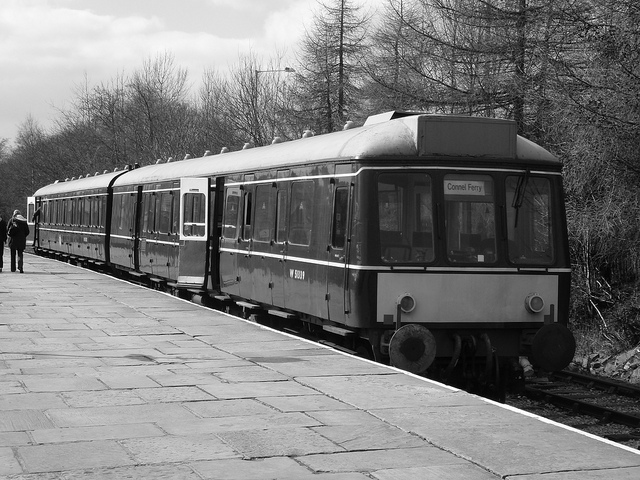What does the sign on the front of the train say? The sign on the front of the train reads 'Cornell Ferg.' It appears to be the name of the train or the destination it serves. 